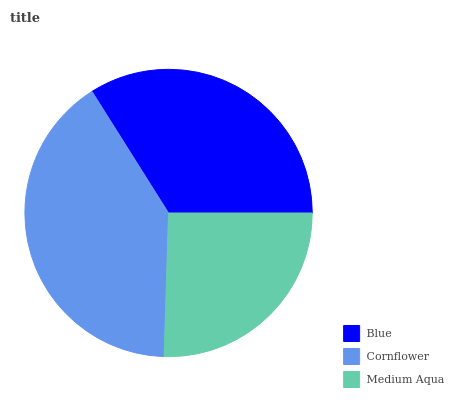Is Medium Aqua the minimum?
Answer yes or no. Yes. Is Cornflower the maximum?
Answer yes or no. Yes. Is Cornflower the minimum?
Answer yes or no. No. Is Medium Aqua the maximum?
Answer yes or no. No. Is Cornflower greater than Medium Aqua?
Answer yes or no. Yes. Is Medium Aqua less than Cornflower?
Answer yes or no. Yes. Is Medium Aqua greater than Cornflower?
Answer yes or no. No. Is Cornflower less than Medium Aqua?
Answer yes or no. No. Is Blue the high median?
Answer yes or no. Yes. Is Blue the low median?
Answer yes or no. Yes. Is Cornflower the high median?
Answer yes or no. No. Is Cornflower the low median?
Answer yes or no. No. 